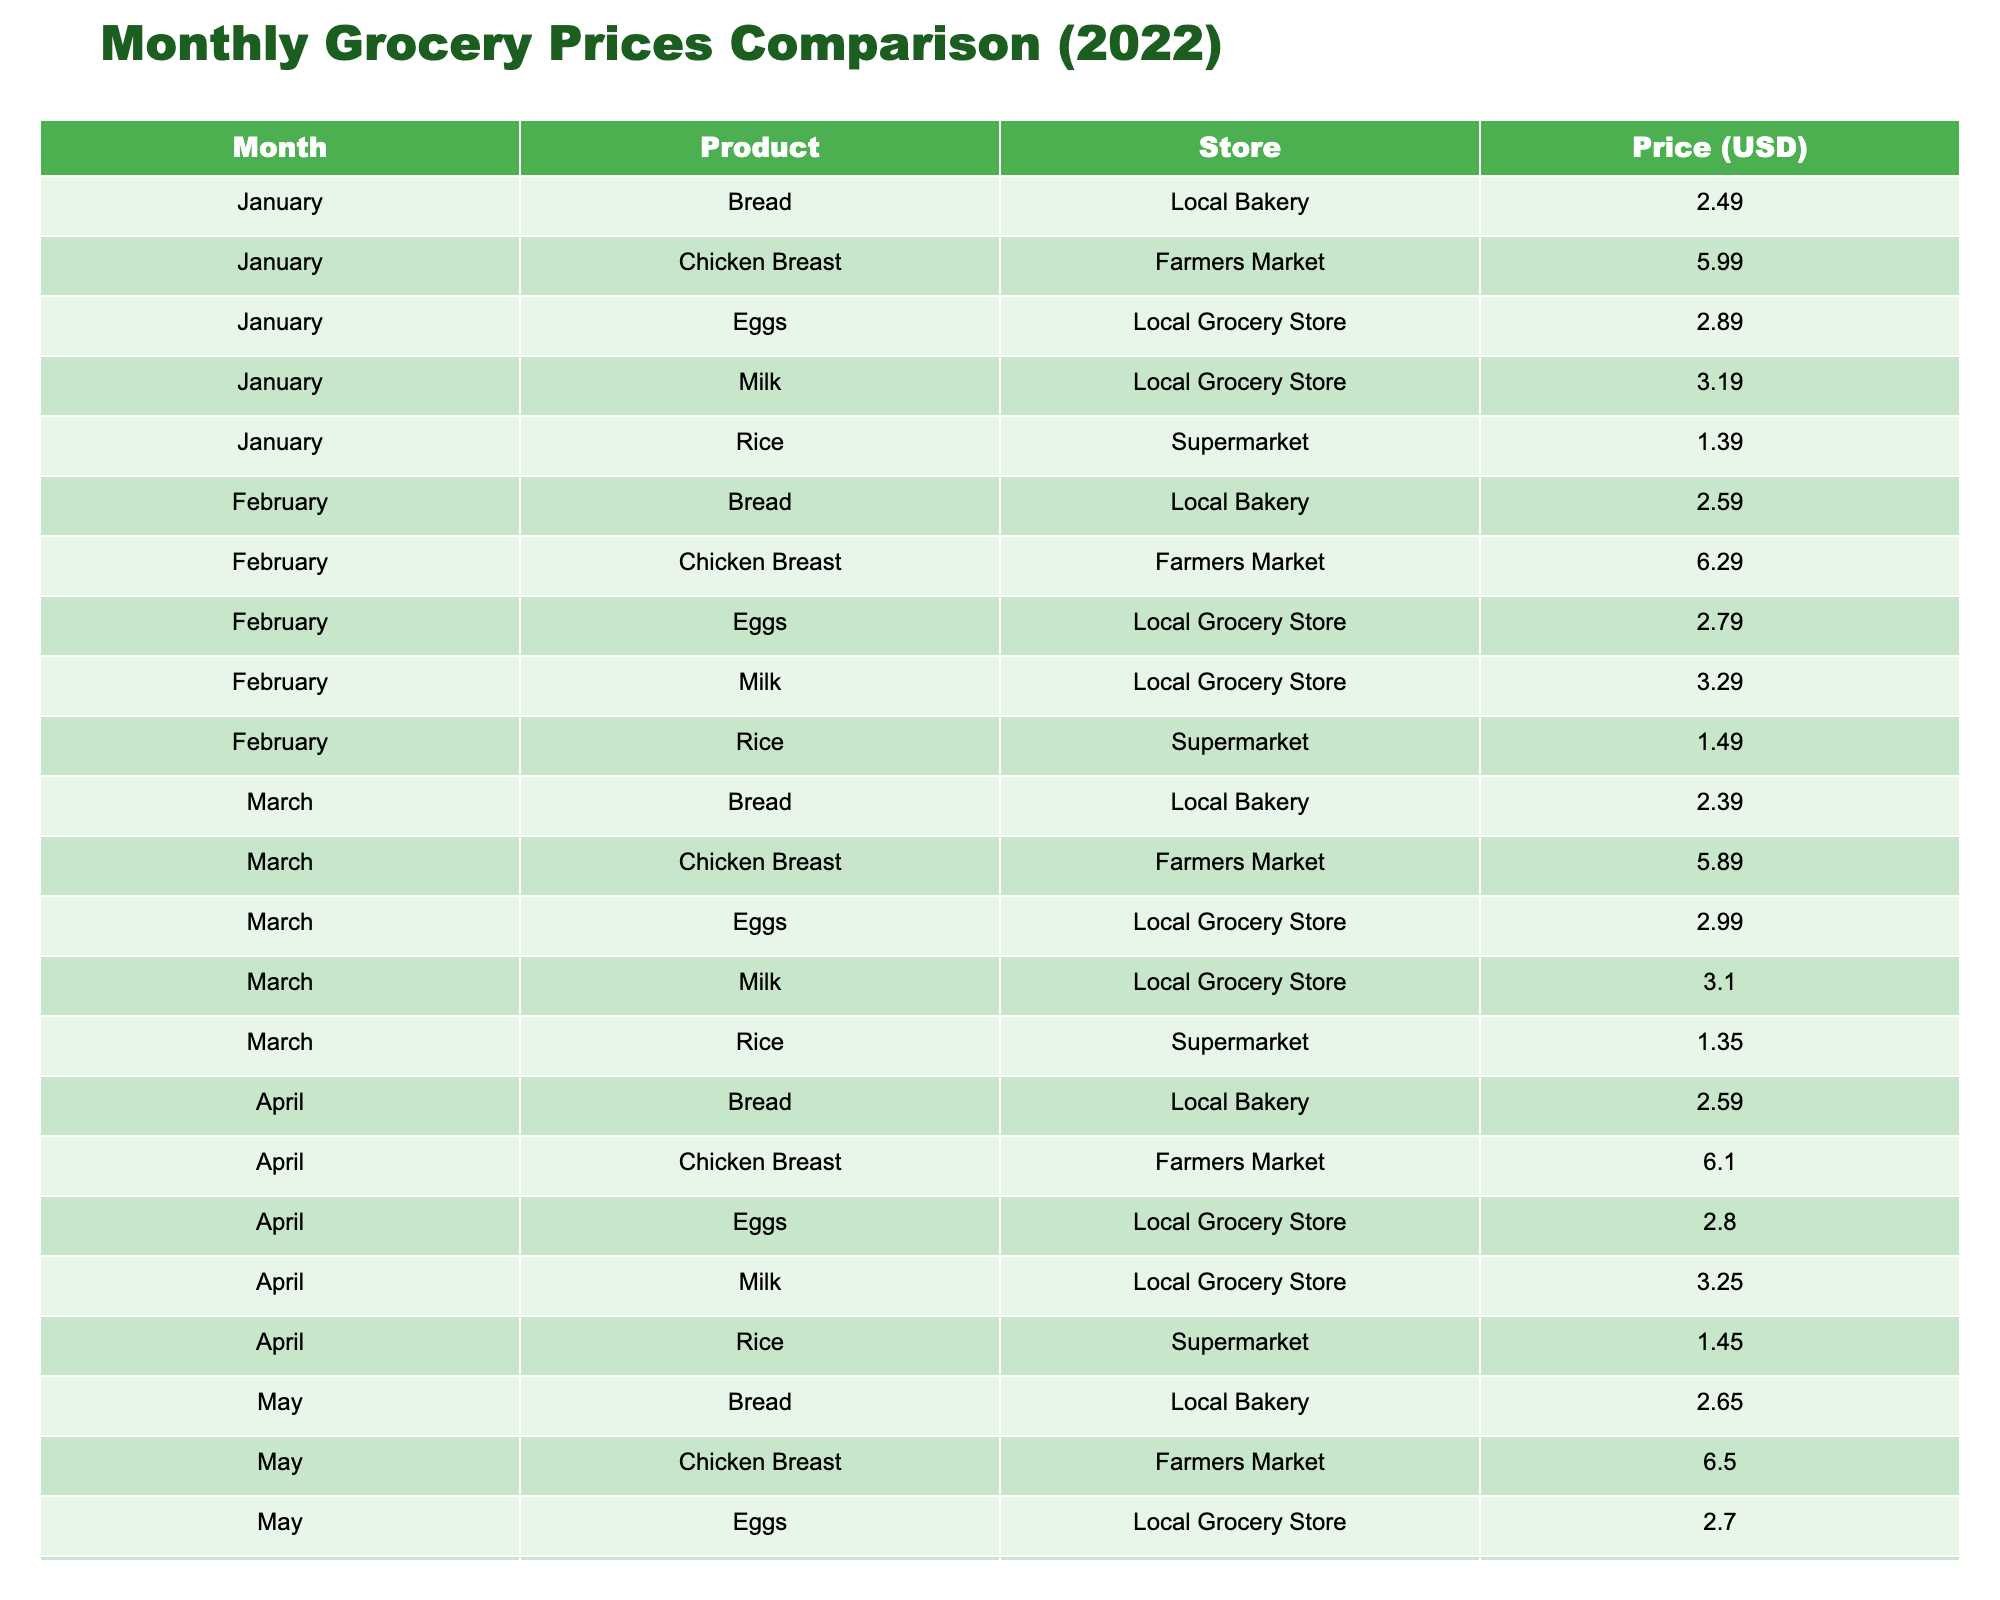What was the price of milk in December? The table shows that in December, the price of milk is listed under the "Milk" row for the month "December." The value given is 3.80.
Answer: 3.80 Which month had the highest price for chicken breast? By reviewing the prices for chicken breast for each month, the highest value is found in December, where it is listed as 6.90.
Answer: December What is the average price of bread over the year? The prices of bread for each month are: 2.49, 2.59, 2.39, 2.59, 2.65, 2.55, 2.70, 2.75, 2.80, 2.85, 2.90, and 3.00. Adding these values gives a total of 31.64, and dividing by 12 months results in an average price of approximately 2.64.
Answer: 2.64 Did the price of rice increase every month? By examining the prices of rice, we see they are: 1.39, 1.49, 1.35, 1.45, 1.40, 1.50, 1.55, 1.60, 1.65, 1.70, 1.75, 1.80. Notice the price decreased in March and May, so it did not increase every month.
Answer: No Which store had the lowest price for eggs in July? In July, the price for eggs at the Local Grocery Store is 2.99. Since eggs prices at this store are compared to others (if any), and there are no other prices listed for eggs in July, we find this is the only price available, thus it's the lowest.
Answer: Local Grocery Store How much more expensive was milk in November compared to January? In November, milk is priced at 3.60, while in January, it is priced at 3.19. The difference is 3.60 - 3.19 = 0.41.
Answer: 0.41 What is the total cost of buying one of each product in October? The October prices for each product are 3.50 (Milk) + 2.85 (Bread) + 6.50 (Chicken Breast) + 1.70 (Rice) + 2.90 (Eggs). Adding these gives a total of 17.45.
Answer: 17.45 Is the average price of chicken breast higher in the second half of the year compared to the first half? The average price for the first half (Jan to June) is calculated as: (5.99 + 6.29 + 5.89 + 6.10 + 6.50 + 6.00) / 6 = 6.11, and for the second half (July to December) it's (6.20 + 6.30 + 6.40 + 6.50 + 6.70 + 6.90) / 6 = 6.54. Since 6.54 is greater than 6.11, the average is indeed higher in the second half.
Answer: Yes Which month had the lowest average price for all products combined? To determine the month with the lowest average price, we add each item's price for all months, calculating averages across all products. Doing this reveals that March has the lowest average price.
Answer: March 